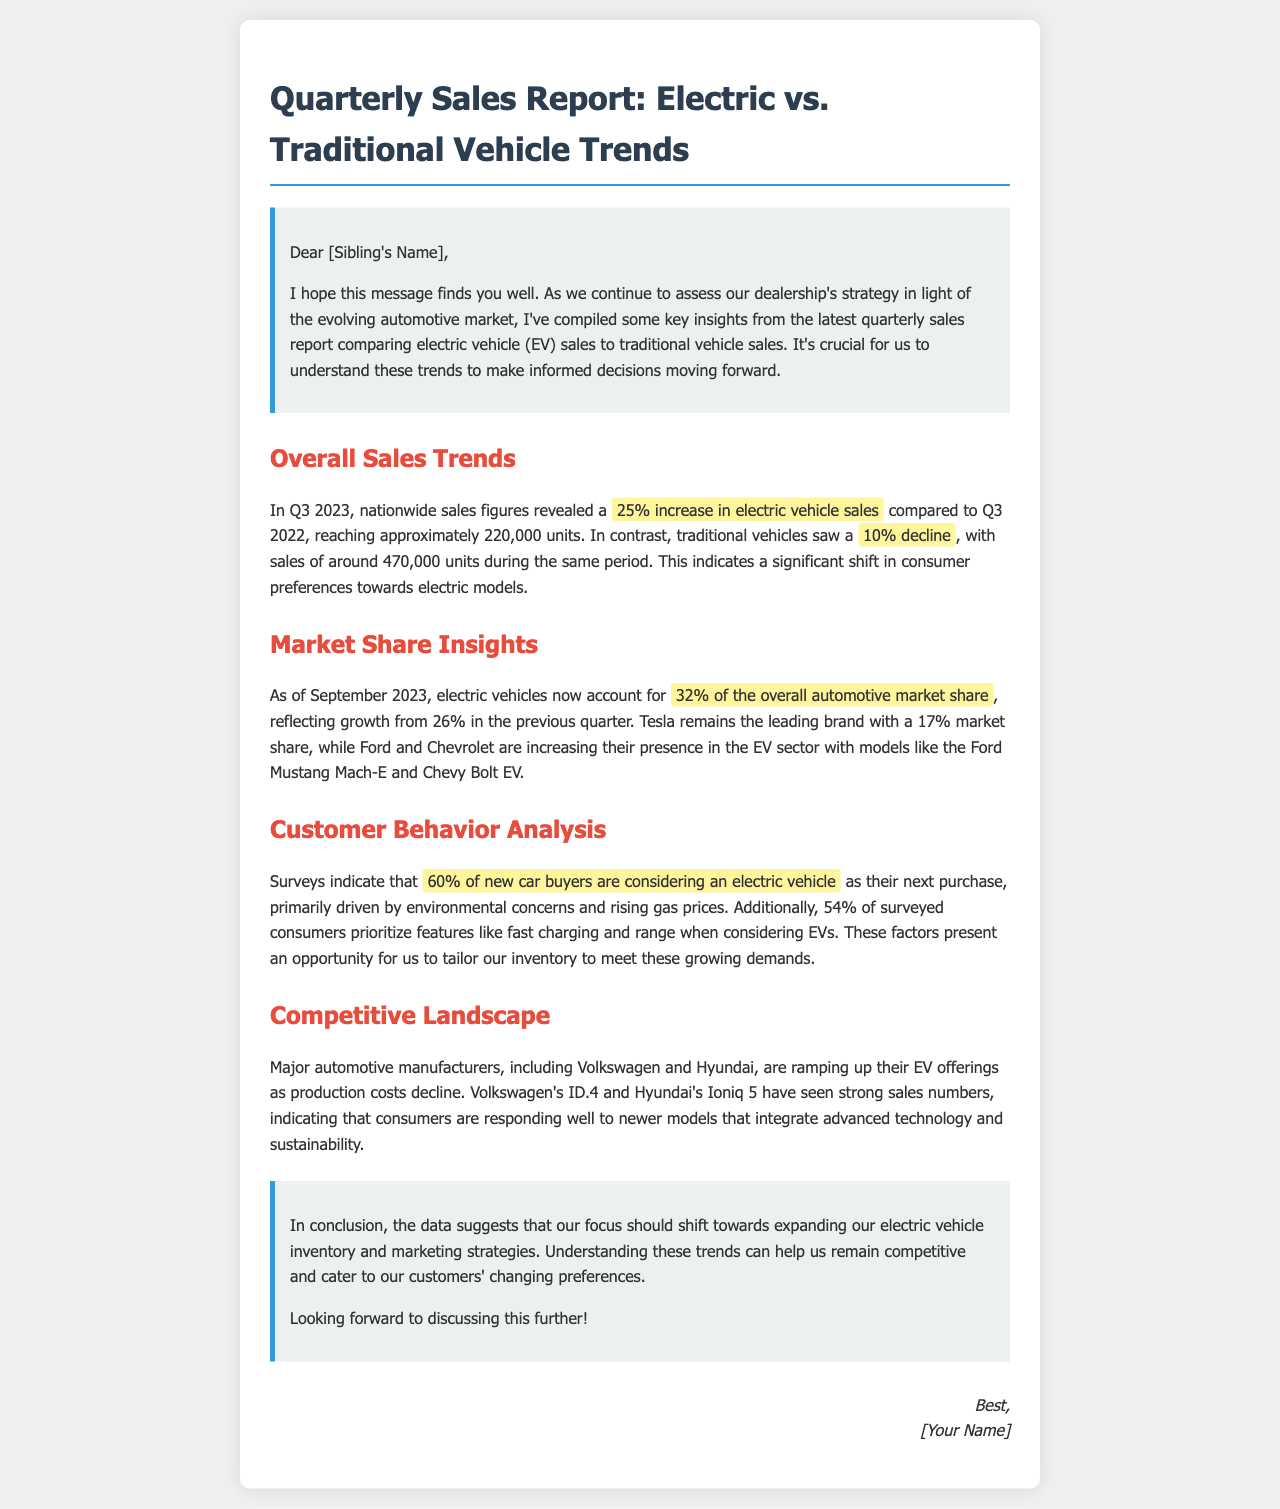What was the percentage increase in electric vehicle sales in Q3 2023? The document states that there was a 25% increase in electric vehicle sales compared to Q3 2022.
Answer: 25% What percentage of the market share do electric vehicles hold as of September 2023? The document mentions that electric vehicles account for 32% of the overall automotive market share as of September 2023.
Answer: 32% Which brand remains the leading electric vehicle manufacturer? According to the document, Tesla remains the leading brand with a 17% market share.
Answer: Tesla What percentage of new car buyers are considering an electric vehicle? The document indicates that 60% of new car buyers are considering an electric vehicle for their next purchase.
Answer: 60% What are two major features consumers prioritize when considering EVs? The document highlights fast charging and range as two key features prioritized by consumers.
Answer: Fast charging and range How much did traditional vehicle sales decline in Q3 2023? It states that traditional vehicles saw a 10% decline during the same period.
Answer: 10% What are the reasons driving consumers towards electric vehicles? The document notes that environmental concerns and rising gas prices are driving consumers towards electric vehicles.
Answer: Environmental concerns and rising gas prices Which two automakers are ramping up their EV offerings? The document mentions Volkswagen and Hyundai as two major automotive manufacturers increasing their EV offerings.
Answer: Volkswagen and Hyundai What did the survey indicate about consumer preferences for EV features? It mentions that 54% of surveyed consumers prioritize fast charging and range when considering EVs.
Answer: Fast charging and range 